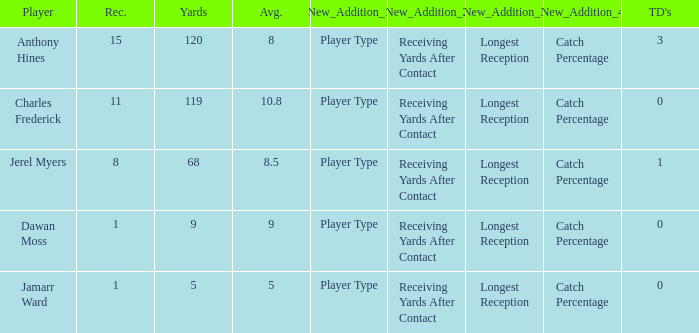I'm looking to parse the entire table for insights. Could you assist me with that? {'header': ['Player', 'Rec.', 'Yards', 'Avg.', 'New_Addition_1', 'New_Addition_2', 'New_Addition_3', 'New_Addition_4', "TD's"], 'rows': [['Anthony Hines', '15', '120', '8', 'Player Type', 'Receiving Yards After Contact', 'Longest Reception', 'Catch Percentage', '3'], ['Charles Frederick', '11', '119', '10.8', 'Player Type', 'Receiving Yards After Contact', 'Longest Reception', 'Catch Percentage', '0'], ['Jerel Myers', '8', '68', '8.5', 'Player Type', 'Receiving Yards After Contact', 'Longest Reception', 'Catch Percentage', '1'], ['Dawan Moss', '1', '9', '9', 'Player Type', 'Receiving Yards After Contact', 'Longest Reception', 'Catch Percentage', '0'], ['Jamarr Ward', '1', '5', '5', 'Player Type', 'Receiving Yards After Contact', 'Longest Reception', 'Catch Percentage', '0']]} What is the average number of TDs when the yards are less than 119, the AVG is larger than 5, and Jamarr Ward is a player? None. 